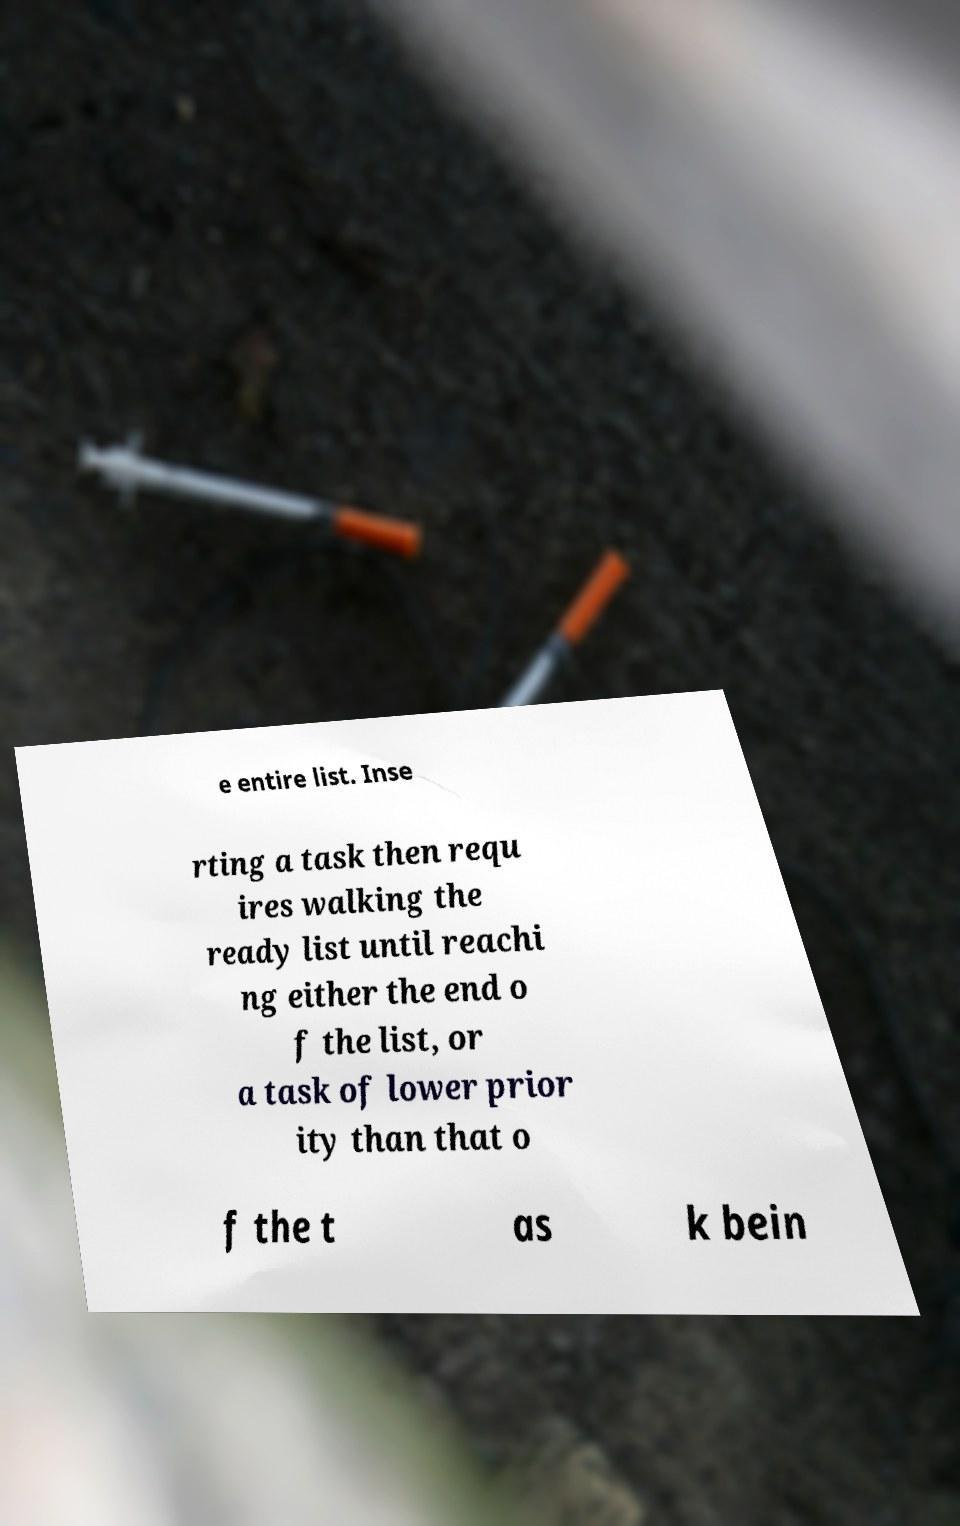For documentation purposes, I need the text within this image transcribed. Could you provide that? e entire list. Inse rting a task then requ ires walking the ready list until reachi ng either the end o f the list, or a task of lower prior ity than that o f the t as k bein 